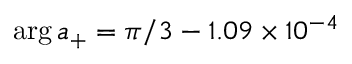<formula> <loc_0><loc_0><loc_500><loc_500>\arg a _ { + } = \pi / 3 - 1 . 0 9 \times 1 0 ^ { - 4 }</formula> 